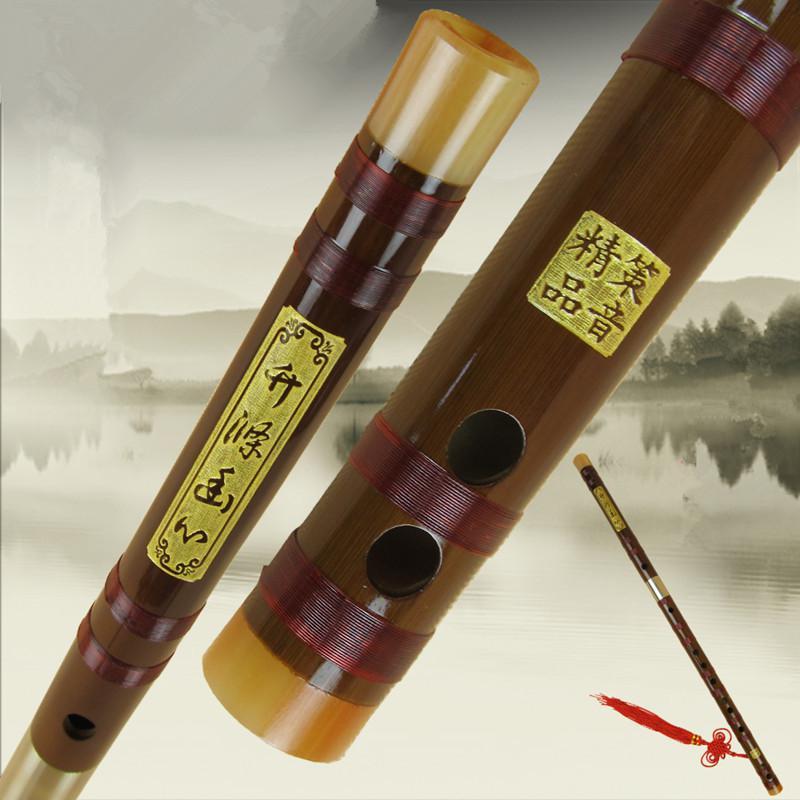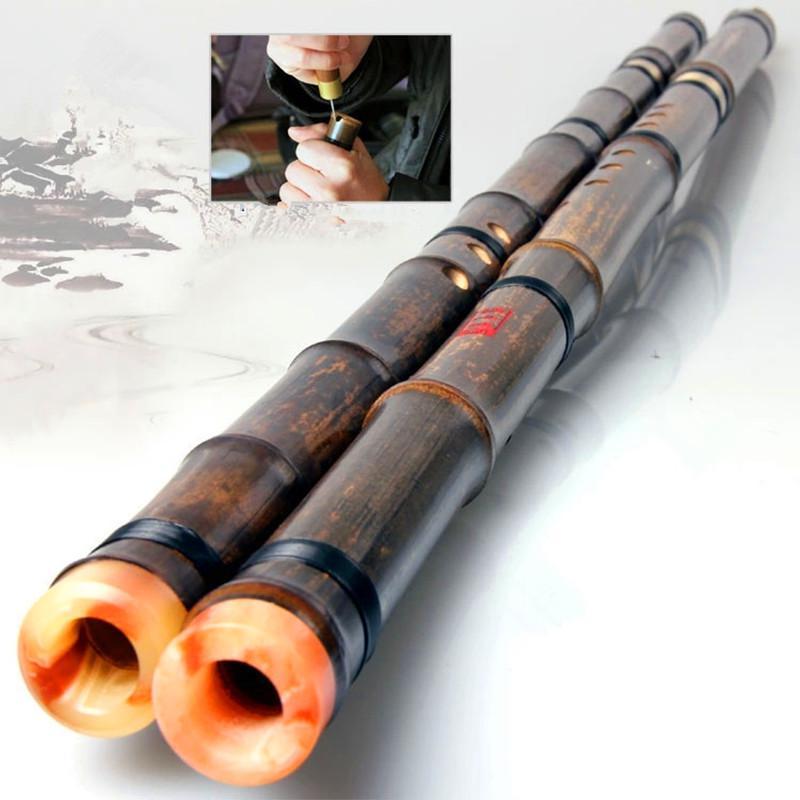The first image is the image on the left, the second image is the image on the right. Considering the images on both sides, is "Exactly two instruments have black bands." valid? Answer yes or no. Yes. The first image is the image on the left, the second image is the image on the right. For the images shown, is this caption "One image shows exactly three wooden flutes, and the other image contains at least one flute displayed diagonally." true? Answer yes or no. No. 